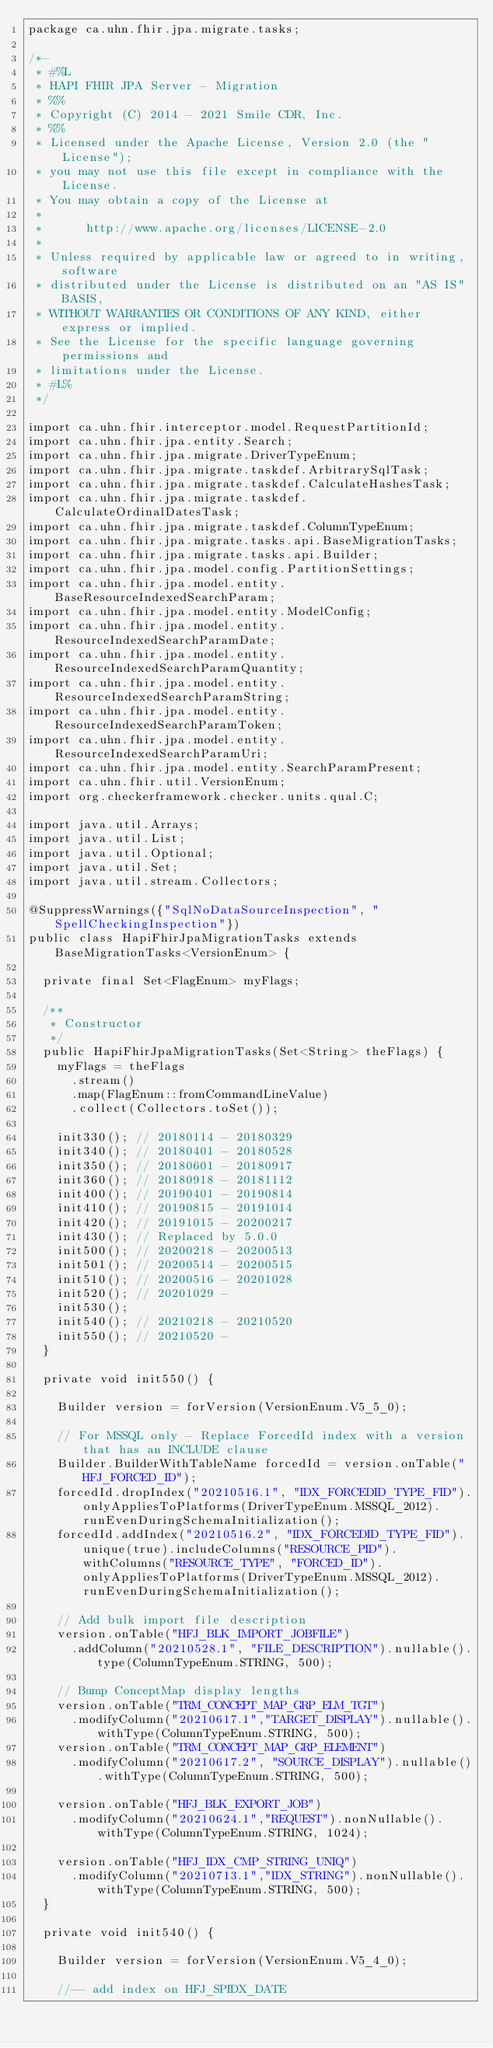Convert code to text. <code><loc_0><loc_0><loc_500><loc_500><_Java_>package ca.uhn.fhir.jpa.migrate.tasks;

/*-
 * #%L
 * HAPI FHIR JPA Server - Migration
 * %%
 * Copyright (C) 2014 - 2021 Smile CDR, Inc.
 * %%
 * Licensed under the Apache License, Version 2.0 (the "License");
 * you may not use this file except in compliance with the License.
 * You may obtain a copy of the License at
 *
 *      http://www.apache.org/licenses/LICENSE-2.0
 *
 * Unless required by applicable law or agreed to in writing, software
 * distributed under the License is distributed on an "AS IS" BASIS,
 * WITHOUT WARRANTIES OR CONDITIONS OF ANY KIND, either express or implied.
 * See the License for the specific language governing permissions and
 * limitations under the License.
 * #L%
 */

import ca.uhn.fhir.interceptor.model.RequestPartitionId;
import ca.uhn.fhir.jpa.entity.Search;
import ca.uhn.fhir.jpa.migrate.DriverTypeEnum;
import ca.uhn.fhir.jpa.migrate.taskdef.ArbitrarySqlTask;
import ca.uhn.fhir.jpa.migrate.taskdef.CalculateHashesTask;
import ca.uhn.fhir.jpa.migrate.taskdef.CalculateOrdinalDatesTask;
import ca.uhn.fhir.jpa.migrate.taskdef.ColumnTypeEnum;
import ca.uhn.fhir.jpa.migrate.tasks.api.BaseMigrationTasks;
import ca.uhn.fhir.jpa.migrate.tasks.api.Builder;
import ca.uhn.fhir.jpa.model.config.PartitionSettings;
import ca.uhn.fhir.jpa.model.entity.BaseResourceIndexedSearchParam;
import ca.uhn.fhir.jpa.model.entity.ModelConfig;
import ca.uhn.fhir.jpa.model.entity.ResourceIndexedSearchParamDate;
import ca.uhn.fhir.jpa.model.entity.ResourceIndexedSearchParamQuantity;
import ca.uhn.fhir.jpa.model.entity.ResourceIndexedSearchParamString;
import ca.uhn.fhir.jpa.model.entity.ResourceIndexedSearchParamToken;
import ca.uhn.fhir.jpa.model.entity.ResourceIndexedSearchParamUri;
import ca.uhn.fhir.jpa.model.entity.SearchParamPresent;
import ca.uhn.fhir.util.VersionEnum;
import org.checkerframework.checker.units.qual.C;

import java.util.Arrays;
import java.util.List;
import java.util.Optional;
import java.util.Set;
import java.util.stream.Collectors;

@SuppressWarnings({"SqlNoDataSourceInspection", "SpellCheckingInspection"})
public class HapiFhirJpaMigrationTasks extends BaseMigrationTasks<VersionEnum> {

	private final Set<FlagEnum> myFlags;

	/**
	 * Constructor
	 */
	public HapiFhirJpaMigrationTasks(Set<String> theFlags) {
		myFlags = theFlags
			.stream()
			.map(FlagEnum::fromCommandLineValue)
			.collect(Collectors.toSet());

		init330(); // 20180114 - 20180329
		init340(); // 20180401 - 20180528
		init350(); // 20180601 - 20180917
		init360(); // 20180918 - 20181112
		init400(); // 20190401 - 20190814
		init410(); // 20190815 - 20191014
		init420(); // 20191015 - 20200217
		init430(); // Replaced by 5.0.0
		init500(); // 20200218 - 20200513
		init501(); // 20200514 - 20200515
		init510(); // 20200516 - 20201028
		init520(); // 20201029 -
		init530();
		init540(); // 20210218 - 20210520
		init550(); // 20210520 -
	}

	private void init550() {

		Builder version = forVersion(VersionEnum.V5_5_0);

		// For MSSQL only - Replace ForcedId index with a version that has an INCLUDE clause
		Builder.BuilderWithTableName forcedId = version.onTable("HFJ_FORCED_ID");
		forcedId.dropIndex("20210516.1", "IDX_FORCEDID_TYPE_FID").onlyAppliesToPlatforms(DriverTypeEnum.MSSQL_2012).runEvenDuringSchemaInitialization();
		forcedId.addIndex("20210516.2", "IDX_FORCEDID_TYPE_FID").unique(true).includeColumns("RESOURCE_PID").withColumns("RESOURCE_TYPE", "FORCED_ID").onlyAppliesToPlatforms(DriverTypeEnum.MSSQL_2012).runEvenDuringSchemaInitialization();

		// Add bulk import file description
		version.onTable("HFJ_BLK_IMPORT_JOBFILE")
			.addColumn("20210528.1", "FILE_DESCRIPTION").nullable().type(ColumnTypeEnum.STRING, 500);

		// Bump ConceptMap display lengths
		version.onTable("TRM_CONCEPT_MAP_GRP_ELM_TGT")
			.modifyColumn("20210617.1","TARGET_DISPLAY").nullable().withType(ColumnTypeEnum.STRING, 500);
		version.onTable("TRM_CONCEPT_MAP_GRP_ELEMENT")
			.modifyColumn("20210617.2", "SOURCE_DISPLAY").nullable().withType(ColumnTypeEnum.STRING, 500);

		version.onTable("HFJ_BLK_EXPORT_JOB")
			.modifyColumn("20210624.1","REQUEST").nonNullable().withType(ColumnTypeEnum.STRING, 1024);

		version.onTable("HFJ_IDX_CMP_STRING_UNIQ")
			.modifyColumn("20210713.1","IDX_STRING").nonNullable().withType(ColumnTypeEnum.STRING, 500);
	}

	private void init540() {

		Builder version = forVersion(VersionEnum.V5_4_0);

		//-- add index on HFJ_SPIDX_DATE</code> 